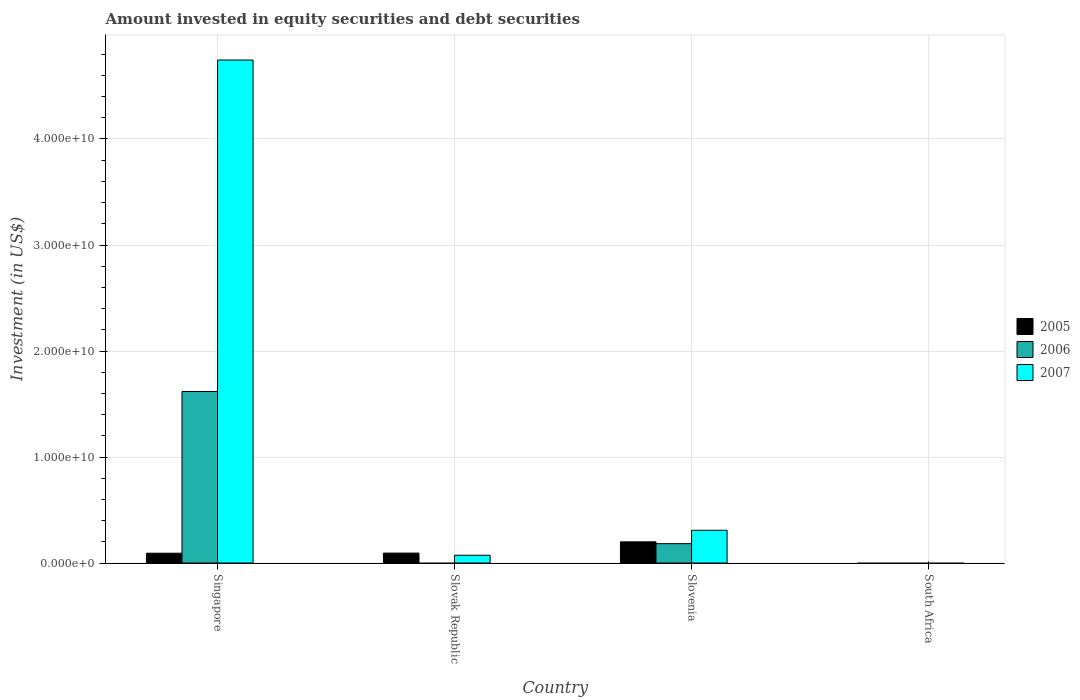How many different coloured bars are there?
Offer a terse response. 3. Are the number of bars per tick equal to the number of legend labels?
Keep it short and to the point. No. How many bars are there on the 4th tick from the right?
Keep it short and to the point. 3. What is the label of the 2nd group of bars from the left?
Give a very brief answer. Slovak Republic. What is the amount invested in equity securities and debt securities in 2007 in Singapore?
Offer a terse response. 4.74e+1. Across all countries, what is the maximum amount invested in equity securities and debt securities in 2006?
Your response must be concise. 1.62e+1. Across all countries, what is the minimum amount invested in equity securities and debt securities in 2005?
Provide a succinct answer. 0. In which country was the amount invested in equity securities and debt securities in 2007 maximum?
Offer a very short reply. Singapore. What is the total amount invested in equity securities and debt securities in 2005 in the graph?
Your response must be concise. 3.86e+09. What is the difference between the amount invested in equity securities and debt securities in 2007 in Singapore and that in Slovenia?
Offer a very short reply. 4.44e+1. What is the difference between the amount invested in equity securities and debt securities in 2005 in Slovenia and the amount invested in equity securities and debt securities in 2007 in Singapore?
Your answer should be very brief. -4.55e+1. What is the average amount invested in equity securities and debt securities in 2006 per country?
Keep it short and to the point. 4.50e+09. What is the difference between the amount invested in equity securities and debt securities of/in 2005 and amount invested in equity securities and debt securities of/in 2006 in Singapore?
Ensure brevity in your answer.  -1.53e+1. What is the ratio of the amount invested in equity securities and debt securities in 2005 in Singapore to that in Slovak Republic?
Make the answer very short. 0.99. What is the difference between the highest and the second highest amount invested in equity securities and debt securities in 2005?
Your answer should be very brief. 1.06e+09. What is the difference between the highest and the lowest amount invested in equity securities and debt securities in 2006?
Give a very brief answer. 1.62e+1. How many countries are there in the graph?
Ensure brevity in your answer.  4. What is the difference between two consecutive major ticks on the Y-axis?
Make the answer very short. 1.00e+1. Are the values on the major ticks of Y-axis written in scientific E-notation?
Offer a terse response. Yes. Does the graph contain grids?
Ensure brevity in your answer.  Yes. How many legend labels are there?
Your response must be concise. 3. How are the legend labels stacked?
Offer a very short reply. Vertical. What is the title of the graph?
Keep it short and to the point. Amount invested in equity securities and debt securities. What is the label or title of the X-axis?
Your response must be concise. Country. What is the label or title of the Y-axis?
Offer a very short reply. Investment (in US$). What is the Investment (in US$) of 2005 in Singapore?
Keep it short and to the point. 9.27e+08. What is the Investment (in US$) in 2006 in Singapore?
Your response must be concise. 1.62e+1. What is the Investment (in US$) in 2007 in Singapore?
Your response must be concise. 4.74e+1. What is the Investment (in US$) of 2005 in Slovak Republic?
Your response must be concise. 9.37e+08. What is the Investment (in US$) of 2007 in Slovak Republic?
Give a very brief answer. 7.34e+08. What is the Investment (in US$) of 2005 in Slovenia?
Provide a succinct answer. 2.00e+09. What is the Investment (in US$) in 2006 in Slovenia?
Give a very brief answer. 1.83e+09. What is the Investment (in US$) in 2007 in Slovenia?
Provide a short and direct response. 3.09e+09. What is the Investment (in US$) in 2006 in South Africa?
Provide a short and direct response. 0. What is the Investment (in US$) in 2007 in South Africa?
Keep it short and to the point. 0. Across all countries, what is the maximum Investment (in US$) of 2005?
Ensure brevity in your answer.  2.00e+09. Across all countries, what is the maximum Investment (in US$) of 2006?
Make the answer very short. 1.62e+1. Across all countries, what is the maximum Investment (in US$) of 2007?
Give a very brief answer. 4.74e+1. Across all countries, what is the minimum Investment (in US$) in 2006?
Ensure brevity in your answer.  0. Across all countries, what is the minimum Investment (in US$) of 2007?
Offer a very short reply. 0. What is the total Investment (in US$) of 2005 in the graph?
Your answer should be compact. 3.86e+09. What is the total Investment (in US$) in 2006 in the graph?
Provide a short and direct response. 1.80e+1. What is the total Investment (in US$) of 2007 in the graph?
Provide a short and direct response. 5.13e+1. What is the difference between the Investment (in US$) in 2005 in Singapore and that in Slovak Republic?
Your response must be concise. -9.90e+06. What is the difference between the Investment (in US$) in 2007 in Singapore and that in Slovak Republic?
Give a very brief answer. 4.67e+1. What is the difference between the Investment (in US$) of 2005 in Singapore and that in Slovenia?
Your answer should be very brief. -1.07e+09. What is the difference between the Investment (in US$) of 2006 in Singapore and that in Slovenia?
Your response must be concise. 1.44e+1. What is the difference between the Investment (in US$) of 2007 in Singapore and that in Slovenia?
Ensure brevity in your answer.  4.44e+1. What is the difference between the Investment (in US$) in 2005 in Slovak Republic and that in Slovenia?
Your answer should be compact. -1.06e+09. What is the difference between the Investment (in US$) in 2007 in Slovak Republic and that in Slovenia?
Keep it short and to the point. -2.35e+09. What is the difference between the Investment (in US$) in 2005 in Singapore and the Investment (in US$) in 2007 in Slovak Republic?
Offer a terse response. 1.92e+08. What is the difference between the Investment (in US$) of 2006 in Singapore and the Investment (in US$) of 2007 in Slovak Republic?
Keep it short and to the point. 1.55e+1. What is the difference between the Investment (in US$) in 2005 in Singapore and the Investment (in US$) in 2006 in Slovenia?
Offer a terse response. -9.00e+08. What is the difference between the Investment (in US$) of 2005 in Singapore and the Investment (in US$) of 2007 in Slovenia?
Make the answer very short. -2.16e+09. What is the difference between the Investment (in US$) in 2006 in Singapore and the Investment (in US$) in 2007 in Slovenia?
Give a very brief answer. 1.31e+1. What is the difference between the Investment (in US$) in 2005 in Slovak Republic and the Investment (in US$) in 2006 in Slovenia?
Provide a succinct answer. -8.90e+08. What is the difference between the Investment (in US$) of 2005 in Slovak Republic and the Investment (in US$) of 2007 in Slovenia?
Provide a succinct answer. -2.15e+09. What is the average Investment (in US$) of 2005 per country?
Ensure brevity in your answer.  9.65e+08. What is the average Investment (in US$) of 2006 per country?
Make the answer very short. 4.50e+09. What is the average Investment (in US$) of 2007 per country?
Offer a terse response. 1.28e+1. What is the difference between the Investment (in US$) of 2005 and Investment (in US$) of 2006 in Singapore?
Make the answer very short. -1.53e+1. What is the difference between the Investment (in US$) of 2005 and Investment (in US$) of 2007 in Singapore?
Provide a succinct answer. -4.65e+1. What is the difference between the Investment (in US$) in 2006 and Investment (in US$) in 2007 in Singapore?
Your answer should be compact. -3.13e+1. What is the difference between the Investment (in US$) of 2005 and Investment (in US$) of 2007 in Slovak Republic?
Your answer should be very brief. 2.02e+08. What is the difference between the Investment (in US$) of 2005 and Investment (in US$) of 2006 in Slovenia?
Give a very brief answer. 1.71e+08. What is the difference between the Investment (in US$) of 2005 and Investment (in US$) of 2007 in Slovenia?
Offer a terse response. -1.09e+09. What is the difference between the Investment (in US$) of 2006 and Investment (in US$) of 2007 in Slovenia?
Make the answer very short. -1.26e+09. What is the ratio of the Investment (in US$) in 2005 in Singapore to that in Slovak Republic?
Your answer should be compact. 0.99. What is the ratio of the Investment (in US$) of 2007 in Singapore to that in Slovak Republic?
Provide a succinct answer. 64.62. What is the ratio of the Investment (in US$) of 2005 in Singapore to that in Slovenia?
Keep it short and to the point. 0.46. What is the ratio of the Investment (in US$) of 2006 in Singapore to that in Slovenia?
Ensure brevity in your answer.  8.86. What is the ratio of the Investment (in US$) of 2007 in Singapore to that in Slovenia?
Your response must be concise. 15.36. What is the ratio of the Investment (in US$) in 2005 in Slovak Republic to that in Slovenia?
Ensure brevity in your answer.  0.47. What is the ratio of the Investment (in US$) of 2007 in Slovak Republic to that in Slovenia?
Your answer should be compact. 0.24. What is the difference between the highest and the second highest Investment (in US$) of 2005?
Ensure brevity in your answer.  1.06e+09. What is the difference between the highest and the second highest Investment (in US$) in 2007?
Provide a succinct answer. 4.44e+1. What is the difference between the highest and the lowest Investment (in US$) of 2005?
Offer a very short reply. 2.00e+09. What is the difference between the highest and the lowest Investment (in US$) of 2006?
Your answer should be compact. 1.62e+1. What is the difference between the highest and the lowest Investment (in US$) in 2007?
Provide a short and direct response. 4.74e+1. 